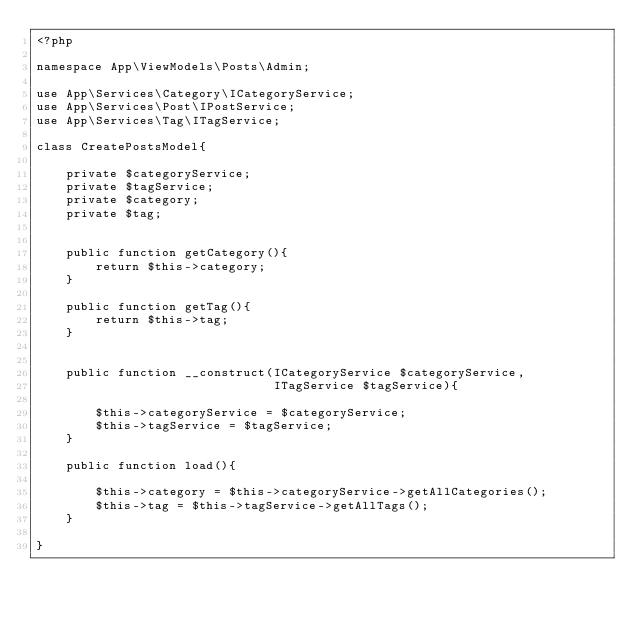<code> <loc_0><loc_0><loc_500><loc_500><_PHP_><?php

namespace App\ViewModels\Posts\Admin;

use App\Services\Category\ICategoryService;
use App\Services\Post\IPostService;
use App\Services\Tag\ITagService;

class CreatePostsModel{

    private $categoryService;
    private $tagService;
    private $category;
    private $tag;


    public function getCategory(){
        return $this->category;
    }

    public function getTag(){
        return $this->tag;
    }


    public function __construct(ICategoryService $categoryService,
                                ITagService $tagService){

        $this->categoryService = $categoryService;
        $this->tagService = $tagService;
    }

    public function load(){

        $this->category = $this->categoryService->getAllCategories();
        $this->tag = $this->tagService->getAllTags();
    }

}
</code> 